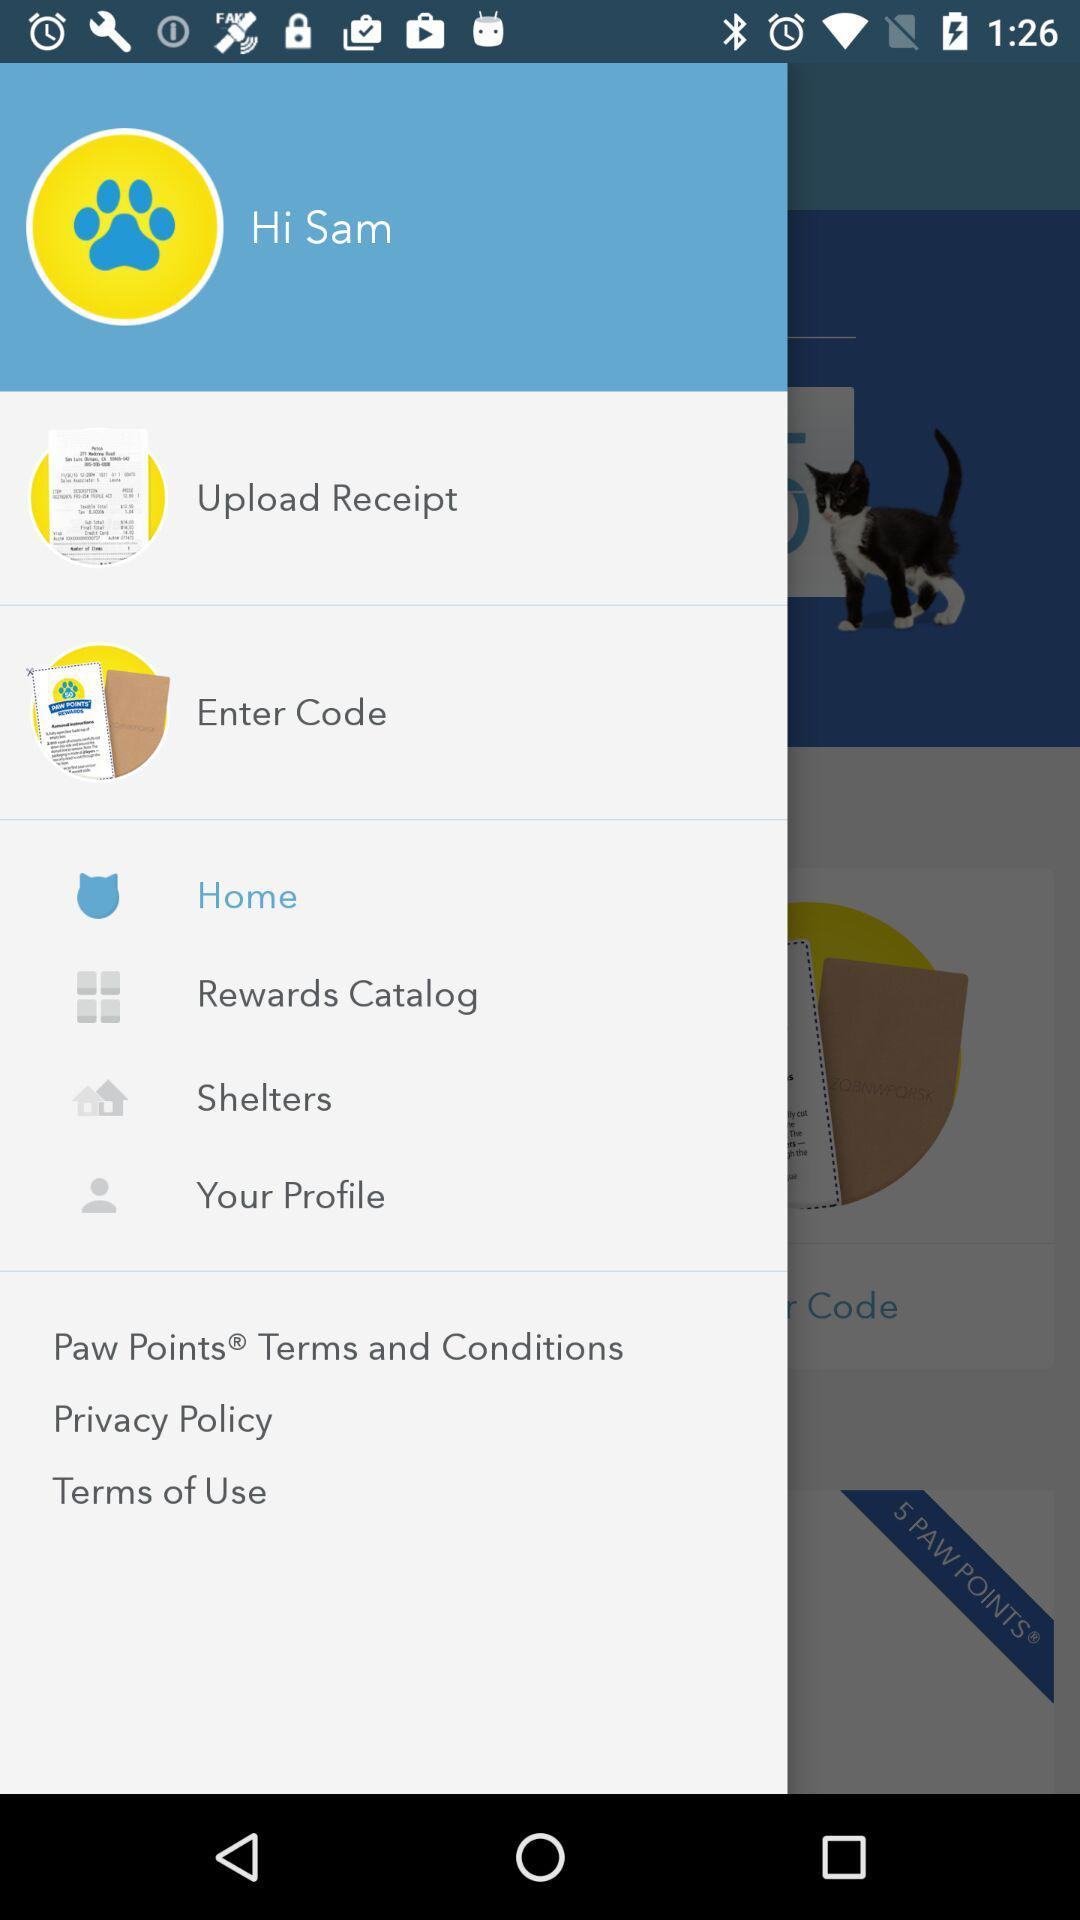How many notifications are there in "Shelters"?
When the provided information is insufficient, respond with <no answer>. <no answer> 